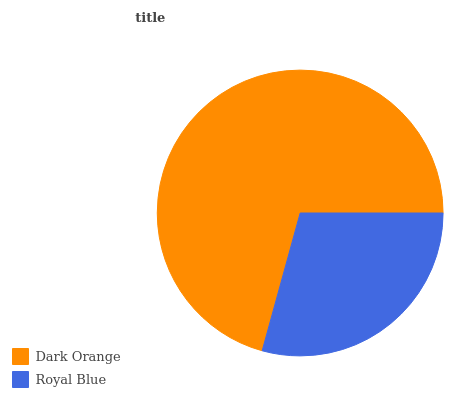Is Royal Blue the minimum?
Answer yes or no. Yes. Is Dark Orange the maximum?
Answer yes or no. Yes. Is Royal Blue the maximum?
Answer yes or no. No. Is Dark Orange greater than Royal Blue?
Answer yes or no. Yes. Is Royal Blue less than Dark Orange?
Answer yes or no. Yes. Is Royal Blue greater than Dark Orange?
Answer yes or no. No. Is Dark Orange less than Royal Blue?
Answer yes or no. No. Is Dark Orange the high median?
Answer yes or no. Yes. Is Royal Blue the low median?
Answer yes or no. Yes. Is Royal Blue the high median?
Answer yes or no. No. Is Dark Orange the low median?
Answer yes or no. No. 